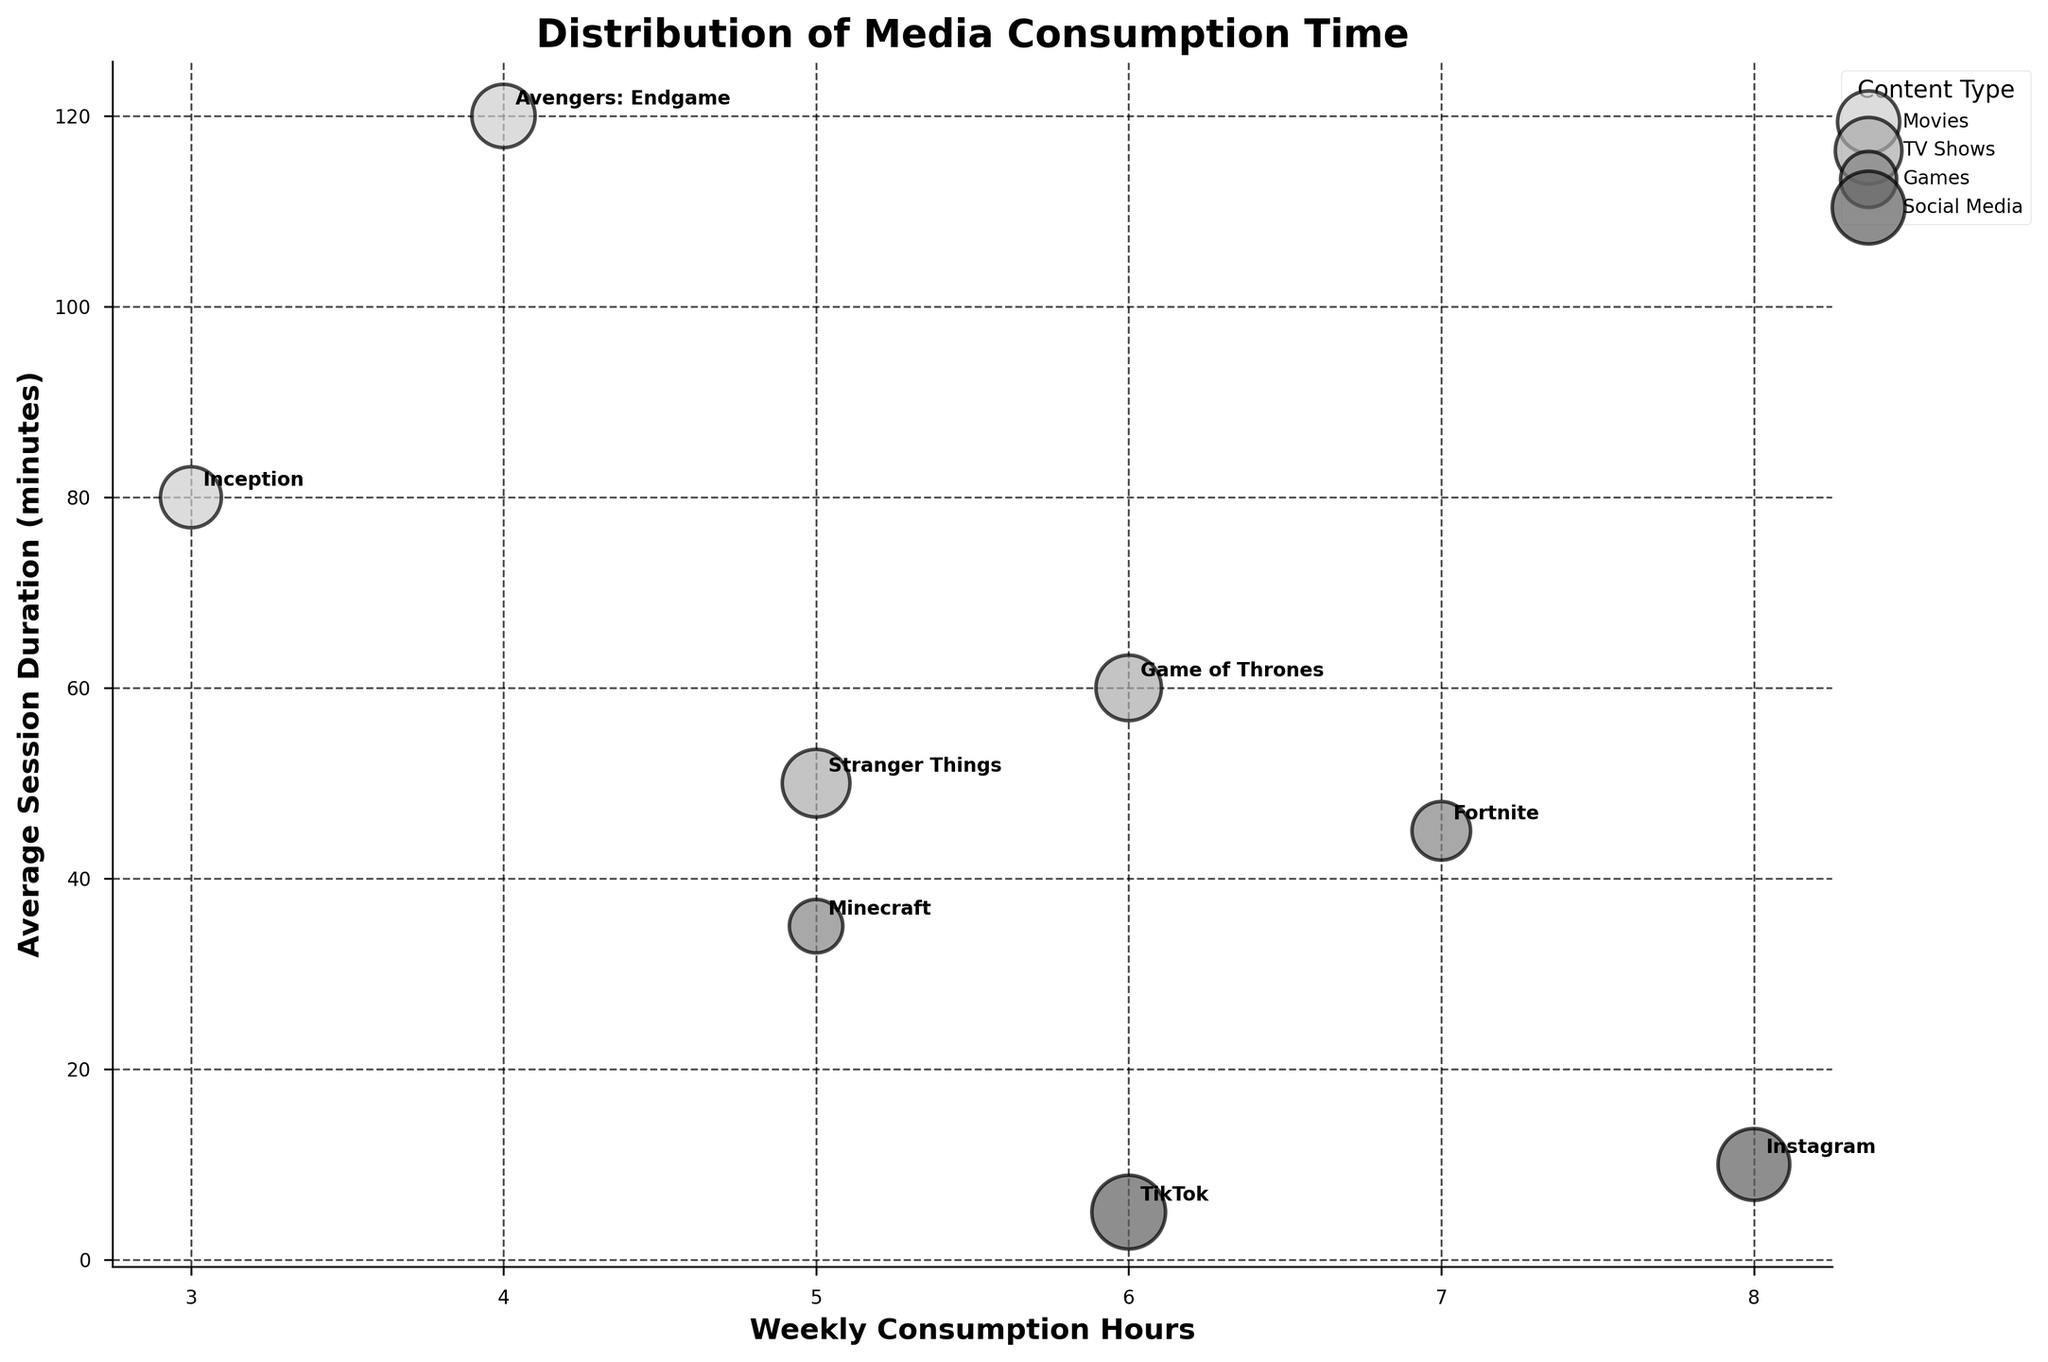what is the title of the chart? The title of the chart is located at the top in a bold font and it reads "Distribution of Media Consumption Time".
Answer: Distribution of Media Consumption Time What is the content type with the highest weekly consumption hours? Among the different content types, Social Media has the highest weekly consumption hours, which can be identified by locating the scatter points furthest to the right on the x-axis.
Answer: Social Media Which media has the shortest average session duration? To find the media with the shortest average session duration, look for the lowest bubble on the y-axis. TikTok, under Social Media, is the lowest point with an average session duration of 5 minutes.
Answer: TikTok How many TV shows are represented in the chart? TV Shows are differentiated by their color and label. By counting the bubbles and annotations specific to TV Shows, there are two TV shows: Stranger Things and Game of Thrones.
Answer: 2 Which media has the largest bubble and what does it represent? The bubbles represent User Saturation percentage scaled up by a factor of 10. The largest bubble signifies the highest user saturation and is TikTok, indicating a 95% user saturation rate.
Answer: TikTok Comparing 'Avengers: Endgame' and 'Inception', which has a higher User Saturation? User Saturation is indicated by the size of the bubbles. 'Avengers: Endgame' and 'Inception' are both part of Movies, and comparing the sizes of their bubbles, Avengers: Endgame has a higher user saturation.
Answer: Avengers: Endgame What is the average session duration for both Games? The two games are Fortnite and Minecraft. Their average session durations are 45 minutes and 35 minutes, respectively. The average is calculated as: (45 + 35) / 2 = 40 minutes.
Answer: 40 minutes Which content type has the most diversified range of weekly consumption hours? By observing the spread of bubbles along the x-axis for each content type, Games have a more diversified range, ranging from 5 hours (Minecraft) to 7 hours (Fortnite), compared to other types which have closer values.
Answer: Games If you sum the weekly consumption hours of all TV shows, what is the result? The weekly consumption hours for TV Shows are 5 hours for Stranger Things and 6 hours for Game of Thrones. Summing these gives 5 + 6 = 11 hours.
Answer: 11 hours Which has more user saturation, 'Stranger Things' or 'Fortnite'? Comparing the sizes of the bubbles for 'Stranger Things' and 'Fortnite', 'Stranger Things' has a larger bubble, indicating higher user saturation.
Answer: Stranger Things 